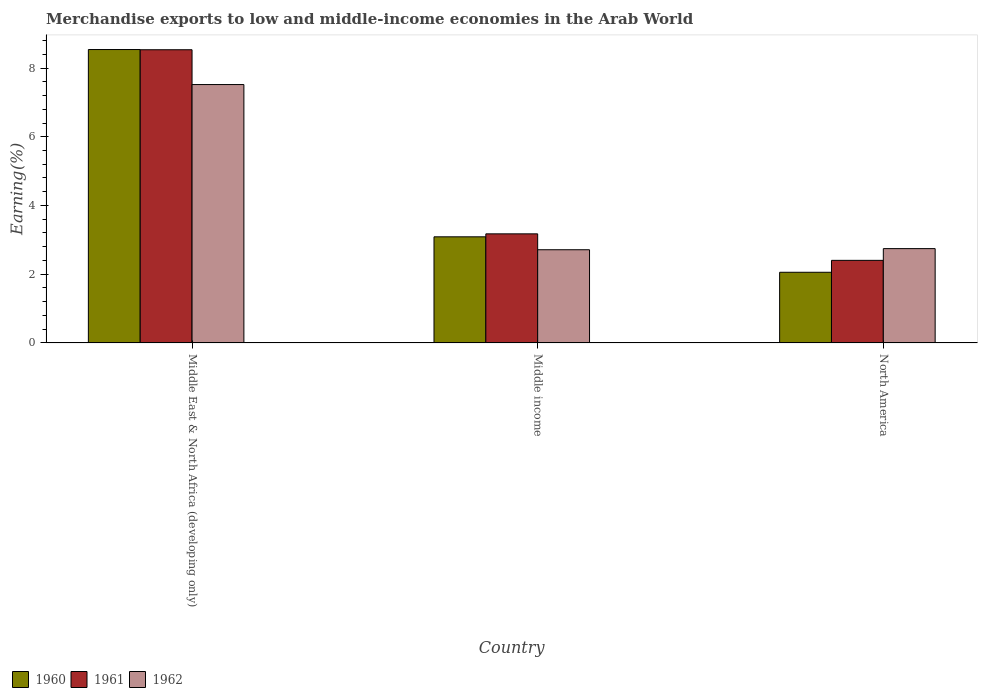How many groups of bars are there?
Your answer should be very brief. 3. Are the number of bars on each tick of the X-axis equal?
Offer a very short reply. Yes. What is the percentage of amount earned from merchandise exports in 1961 in North America?
Provide a succinct answer. 2.4. Across all countries, what is the maximum percentage of amount earned from merchandise exports in 1961?
Provide a short and direct response. 8.53. Across all countries, what is the minimum percentage of amount earned from merchandise exports in 1960?
Provide a succinct answer. 2.06. In which country was the percentage of amount earned from merchandise exports in 1960 maximum?
Your answer should be very brief. Middle East & North Africa (developing only). In which country was the percentage of amount earned from merchandise exports in 1960 minimum?
Your answer should be very brief. North America. What is the total percentage of amount earned from merchandise exports in 1962 in the graph?
Provide a short and direct response. 12.98. What is the difference between the percentage of amount earned from merchandise exports in 1961 in Middle East & North Africa (developing only) and that in Middle income?
Provide a short and direct response. 5.36. What is the difference between the percentage of amount earned from merchandise exports in 1962 in Middle East & North Africa (developing only) and the percentage of amount earned from merchandise exports in 1960 in Middle income?
Provide a succinct answer. 4.43. What is the average percentage of amount earned from merchandise exports in 1960 per country?
Provide a short and direct response. 4.56. What is the difference between the percentage of amount earned from merchandise exports of/in 1960 and percentage of amount earned from merchandise exports of/in 1961 in North America?
Ensure brevity in your answer.  -0.35. In how many countries, is the percentage of amount earned from merchandise exports in 1962 greater than 8 %?
Provide a succinct answer. 0. What is the ratio of the percentage of amount earned from merchandise exports in 1962 in Middle East & North Africa (developing only) to that in North America?
Your response must be concise. 2.74. Is the percentage of amount earned from merchandise exports in 1960 in Middle East & North Africa (developing only) less than that in Middle income?
Provide a short and direct response. No. Is the difference between the percentage of amount earned from merchandise exports in 1960 in Middle East & North Africa (developing only) and Middle income greater than the difference between the percentage of amount earned from merchandise exports in 1961 in Middle East & North Africa (developing only) and Middle income?
Ensure brevity in your answer.  Yes. What is the difference between the highest and the second highest percentage of amount earned from merchandise exports in 1962?
Your answer should be very brief. 0.03. What is the difference between the highest and the lowest percentage of amount earned from merchandise exports in 1961?
Offer a terse response. 6.13. In how many countries, is the percentage of amount earned from merchandise exports in 1962 greater than the average percentage of amount earned from merchandise exports in 1962 taken over all countries?
Your answer should be very brief. 1. Is the sum of the percentage of amount earned from merchandise exports in 1961 in Middle East & North Africa (developing only) and Middle income greater than the maximum percentage of amount earned from merchandise exports in 1960 across all countries?
Your answer should be very brief. Yes. What does the 2nd bar from the right in Middle East & North Africa (developing only) represents?
Offer a very short reply. 1961. Is it the case that in every country, the sum of the percentage of amount earned from merchandise exports in 1961 and percentage of amount earned from merchandise exports in 1962 is greater than the percentage of amount earned from merchandise exports in 1960?
Your answer should be compact. Yes. Are all the bars in the graph horizontal?
Give a very brief answer. No. How many legend labels are there?
Your answer should be very brief. 3. What is the title of the graph?
Your answer should be very brief. Merchandise exports to low and middle-income economies in the Arab World. What is the label or title of the Y-axis?
Your response must be concise. Earning(%). What is the Earning(%) of 1960 in Middle East & North Africa (developing only)?
Offer a very short reply. 8.54. What is the Earning(%) in 1961 in Middle East & North Africa (developing only)?
Your answer should be very brief. 8.53. What is the Earning(%) of 1962 in Middle East & North Africa (developing only)?
Your answer should be very brief. 7.52. What is the Earning(%) of 1960 in Middle income?
Offer a terse response. 3.09. What is the Earning(%) in 1961 in Middle income?
Provide a short and direct response. 3.17. What is the Earning(%) in 1962 in Middle income?
Your response must be concise. 2.71. What is the Earning(%) of 1960 in North America?
Give a very brief answer. 2.06. What is the Earning(%) in 1961 in North America?
Give a very brief answer. 2.4. What is the Earning(%) in 1962 in North America?
Your answer should be very brief. 2.74. Across all countries, what is the maximum Earning(%) in 1960?
Make the answer very short. 8.54. Across all countries, what is the maximum Earning(%) in 1961?
Your answer should be very brief. 8.53. Across all countries, what is the maximum Earning(%) in 1962?
Give a very brief answer. 7.52. Across all countries, what is the minimum Earning(%) in 1960?
Make the answer very short. 2.06. Across all countries, what is the minimum Earning(%) of 1961?
Provide a succinct answer. 2.4. Across all countries, what is the minimum Earning(%) in 1962?
Give a very brief answer. 2.71. What is the total Earning(%) of 1960 in the graph?
Offer a very short reply. 13.68. What is the total Earning(%) in 1961 in the graph?
Your answer should be very brief. 14.11. What is the total Earning(%) in 1962 in the graph?
Your response must be concise. 12.98. What is the difference between the Earning(%) of 1960 in Middle East & North Africa (developing only) and that in Middle income?
Your answer should be very brief. 5.45. What is the difference between the Earning(%) in 1961 in Middle East & North Africa (developing only) and that in Middle income?
Offer a terse response. 5.36. What is the difference between the Earning(%) of 1962 in Middle East & North Africa (developing only) and that in Middle income?
Offer a very short reply. 4.81. What is the difference between the Earning(%) of 1960 in Middle East & North Africa (developing only) and that in North America?
Offer a terse response. 6.48. What is the difference between the Earning(%) of 1961 in Middle East & North Africa (developing only) and that in North America?
Offer a very short reply. 6.13. What is the difference between the Earning(%) in 1962 in Middle East & North Africa (developing only) and that in North America?
Provide a succinct answer. 4.77. What is the difference between the Earning(%) of 1960 in Middle income and that in North America?
Your response must be concise. 1.03. What is the difference between the Earning(%) of 1961 in Middle income and that in North America?
Your answer should be compact. 0.77. What is the difference between the Earning(%) in 1962 in Middle income and that in North America?
Your response must be concise. -0.03. What is the difference between the Earning(%) in 1960 in Middle East & North Africa (developing only) and the Earning(%) in 1961 in Middle income?
Make the answer very short. 5.36. What is the difference between the Earning(%) in 1960 in Middle East & North Africa (developing only) and the Earning(%) in 1962 in Middle income?
Your response must be concise. 5.83. What is the difference between the Earning(%) of 1961 in Middle East & North Africa (developing only) and the Earning(%) of 1962 in Middle income?
Provide a short and direct response. 5.82. What is the difference between the Earning(%) of 1960 in Middle East & North Africa (developing only) and the Earning(%) of 1961 in North America?
Provide a short and direct response. 6.13. What is the difference between the Earning(%) of 1960 in Middle East & North Africa (developing only) and the Earning(%) of 1962 in North America?
Make the answer very short. 5.79. What is the difference between the Earning(%) in 1961 in Middle East & North Africa (developing only) and the Earning(%) in 1962 in North America?
Your answer should be very brief. 5.79. What is the difference between the Earning(%) in 1960 in Middle income and the Earning(%) in 1961 in North America?
Give a very brief answer. 0.68. What is the difference between the Earning(%) of 1960 in Middle income and the Earning(%) of 1962 in North America?
Make the answer very short. 0.34. What is the difference between the Earning(%) of 1961 in Middle income and the Earning(%) of 1962 in North America?
Your answer should be very brief. 0.43. What is the average Earning(%) of 1960 per country?
Provide a succinct answer. 4.56. What is the average Earning(%) in 1961 per country?
Provide a short and direct response. 4.7. What is the average Earning(%) of 1962 per country?
Provide a short and direct response. 4.33. What is the difference between the Earning(%) of 1960 and Earning(%) of 1961 in Middle East & North Africa (developing only)?
Your answer should be very brief. 0.01. What is the difference between the Earning(%) of 1960 and Earning(%) of 1962 in Middle East & North Africa (developing only)?
Your response must be concise. 1.02. What is the difference between the Earning(%) of 1961 and Earning(%) of 1962 in Middle East & North Africa (developing only)?
Your answer should be compact. 1.01. What is the difference between the Earning(%) in 1960 and Earning(%) in 1961 in Middle income?
Your answer should be compact. -0.09. What is the difference between the Earning(%) of 1960 and Earning(%) of 1962 in Middle income?
Give a very brief answer. 0.38. What is the difference between the Earning(%) in 1961 and Earning(%) in 1962 in Middle income?
Give a very brief answer. 0.46. What is the difference between the Earning(%) of 1960 and Earning(%) of 1961 in North America?
Your answer should be compact. -0.35. What is the difference between the Earning(%) in 1960 and Earning(%) in 1962 in North America?
Offer a terse response. -0.69. What is the difference between the Earning(%) of 1961 and Earning(%) of 1962 in North America?
Provide a succinct answer. -0.34. What is the ratio of the Earning(%) of 1960 in Middle East & North Africa (developing only) to that in Middle income?
Give a very brief answer. 2.76. What is the ratio of the Earning(%) of 1961 in Middle East & North Africa (developing only) to that in Middle income?
Provide a succinct answer. 2.69. What is the ratio of the Earning(%) in 1962 in Middle East & North Africa (developing only) to that in Middle income?
Your answer should be compact. 2.77. What is the ratio of the Earning(%) of 1960 in Middle East & North Africa (developing only) to that in North America?
Provide a short and direct response. 4.15. What is the ratio of the Earning(%) of 1961 in Middle East & North Africa (developing only) to that in North America?
Your response must be concise. 3.55. What is the ratio of the Earning(%) in 1962 in Middle East & North Africa (developing only) to that in North America?
Your answer should be very brief. 2.74. What is the ratio of the Earning(%) of 1960 in Middle income to that in North America?
Provide a succinct answer. 1.5. What is the ratio of the Earning(%) of 1961 in Middle income to that in North America?
Provide a succinct answer. 1.32. What is the ratio of the Earning(%) of 1962 in Middle income to that in North America?
Provide a short and direct response. 0.99. What is the difference between the highest and the second highest Earning(%) of 1960?
Offer a very short reply. 5.45. What is the difference between the highest and the second highest Earning(%) of 1961?
Offer a very short reply. 5.36. What is the difference between the highest and the second highest Earning(%) of 1962?
Offer a terse response. 4.77. What is the difference between the highest and the lowest Earning(%) of 1960?
Give a very brief answer. 6.48. What is the difference between the highest and the lowest Earning(%) in 1961?
Your answer should be very brief. 6.13. What is the difference between the highest and the lowest Earning(%) of 1962?
Provide a short and direct response. 4.81. 